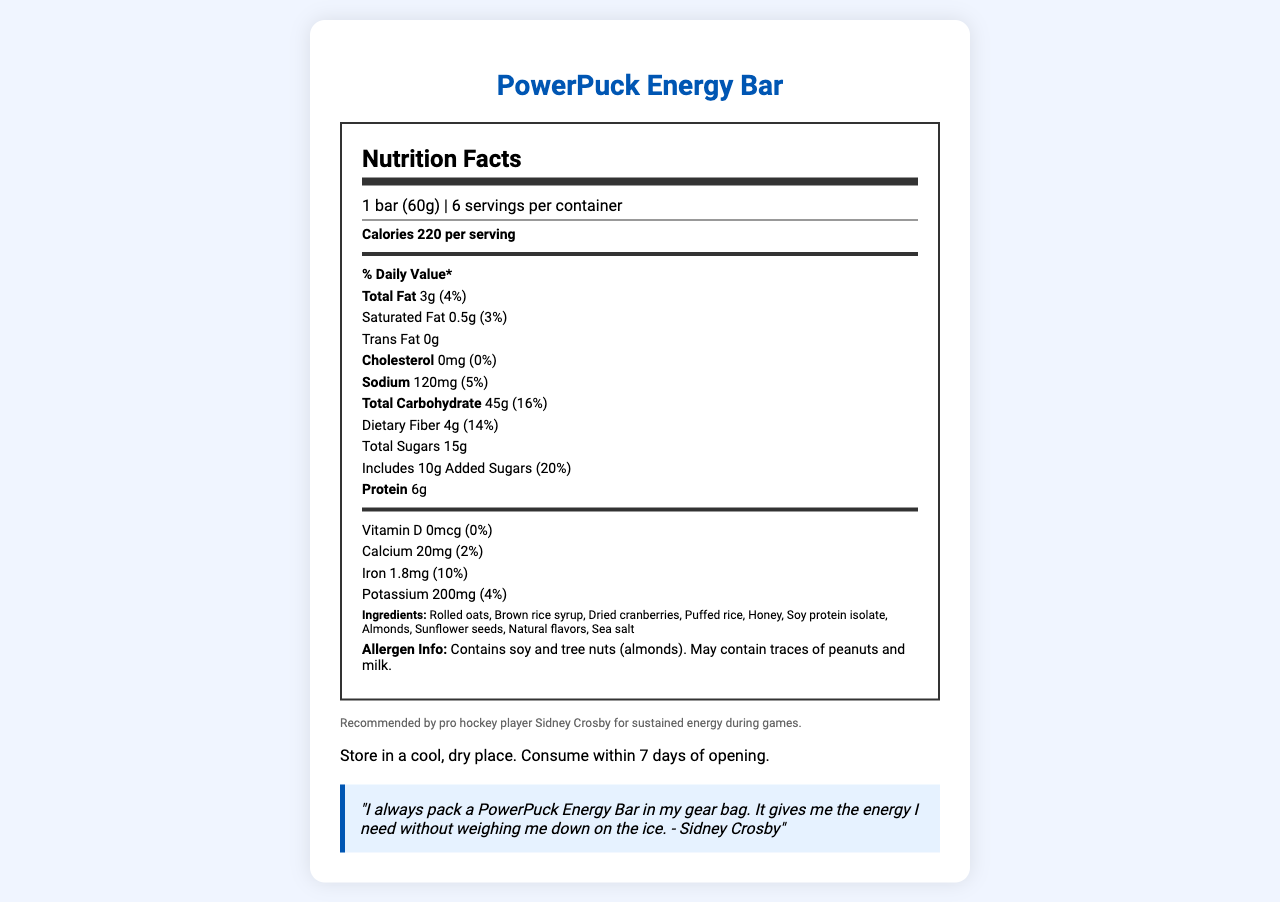what is the serving size of the PowerPuck Energy Bar? The serving size is clearly stated at the beginning of the document as "1 bar (60g)".
Answer: 1 bar (60g) how many calories are in one serving of the PowerPuck Energy Bar? The document specifies that each serving contains 220 calories.
Answer: 220 List the main ingredients in the PowerPuck Energy Bar. The ingredient list is clearly provided in the document.
Answer: Rolled oats, Brown rice syrup, Dried cranberries, Puffed rice, Honey, Soy protein isolate, Almonds, Sunflower seeds, Natural flavors, Sea salt does the PowerPuck Energy Bar contain any trans fat? The document states "Trans Fat 0g", indicating there are no trans fats in the energy bar.
Answer: No What allergens are present in the PowerPuck Energy Bar? The allergen information section specifies "Contains soy and tree nuts (almonds)."
Answer: Soy and tree nuts (almonds) The PowerPuck Energy Bar is recommended by which professional hockey player? A. Alex Ovechkin B. Sidney Crosby C. Connor McDavid D. Auston Matthews The document mentions that the bar is recommended by professional hockey player Sidney Crosby.
Answer: B Which nutrient has the highest % Daily Value (DV) in the PowerPuck Energy Bar? A. Dietary Fiber B. Saturated Fat C. Added Sugars D. Sodium Added Sugars have a 20% DV, which is the highest among the listed nutrients.
Answer: C Does the document mention any vitamin D content in the PowerPuck Energy Bar? The document states "Vitamin D 0mcg (0%)", indicating there is no vitamin D content.
Answer: No Summarize the main idea of the PowerPuck Energy Bar nutrition label. The label gives an overview of the product, emphasizing its energy-boosting qualities with specific nutritional values, ingredients, and endorsement by an athlete.
Answer: The document provides detailed nutritional information for the PowerPuck Energy Bar, including calories, fat, carbs, protein, vitamins, and minerals per serving. It highlights the bar's low-fat, high-carb content and presents it as a recommended source of energy endorsed by pro hockey player Sidney Crosby. The document also includes ingredient details and allergen information. What is the main source of carbohydrates in the PowerPuck Energy Bar? The document does not specifically break down the sources of carbohydrates; it only lists the total carbohydrate content.
Answer: Cannot be determined What should you do after opening the PowerPuck Energy Bar? A. Store in the refrigerator B. Consume within a week C. Freeze it D. Store in a warm place The document advises "Consume within 7 days of opening."
Answer: B How much protein is in one PowerPuck Energy Bar? The document lists the protein content as 6g per serving.
Answer: 6g Are there any preservatives listed in the PowerPuck Energy Bar ingredients? The ingredient list does not mention any preservatives, indicating that no preservatives are used.
Answer: No Which statement is true about the sodium content in the PowerPuck Energy Bar? A. It contains 120mg of sodium, which is 10% DV B. It contains 120mg of sodium, which is 5% DV C. It contains 240mg of sodium, which is 20% DV D. It contains 240mg of sodium, which is 5% DV The document states that the PowerPuck Energy Bar contains 120mg of sodium, which is 5% of the daily value.
Answer: B Is there any cholesterol in the PowerPuck Energy Bar? The nutrition label states that the PowerPuck Energy Bar has "Cholesterol 0mg (0%)", indicating there is no cholesterol content.
Answer: No 